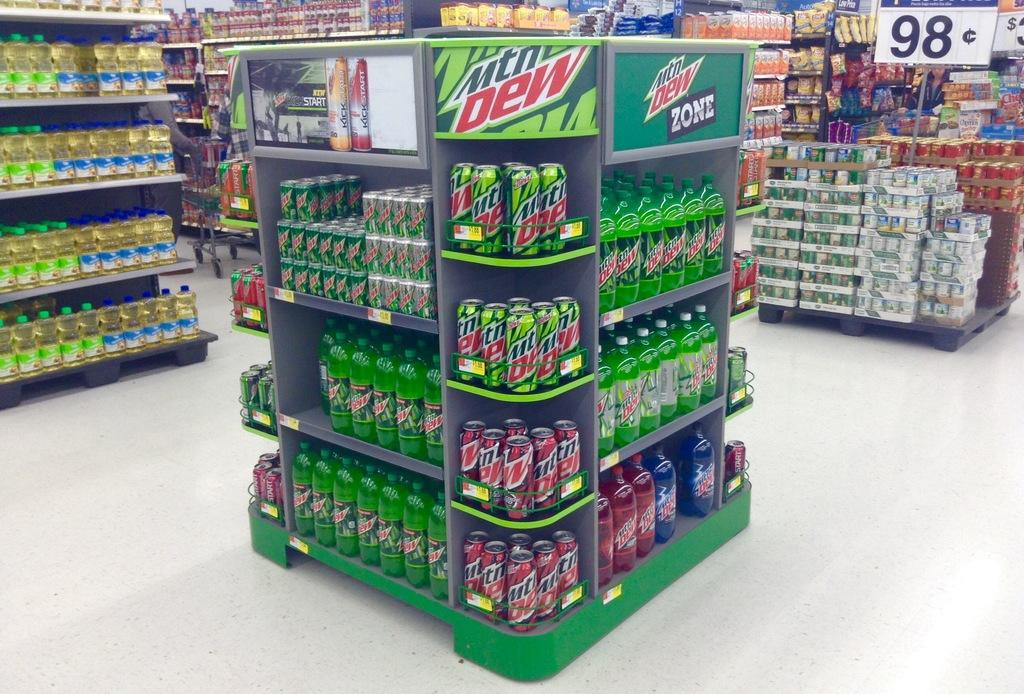<image>
Render a clear and concise summary of the photo. A display in the middle of a grocery store for Mtn Dew. 